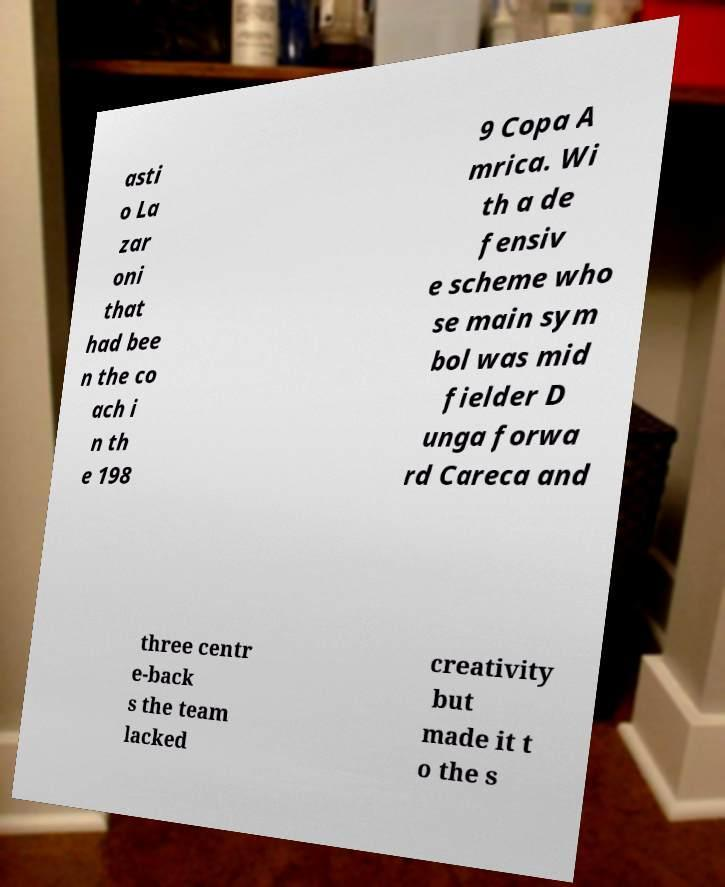There's text embedded in this image that I need extracted. Can you transcribe it verbatim? asti o La zar oni that had bee n the co ach i n th e 198 9 Copa A mrica. Wi th a de fensiv e scheme who se main sym bol was mid fielder D unga forwa rd Careca and three centr e-back s the team lacked creativity but made it t o the s 